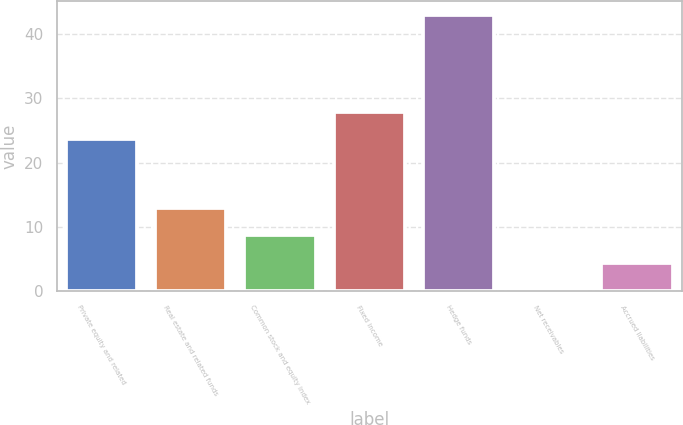Convert chart to OTSL. <chart><loc_0><loc_0><loc_500><loc_500><bar_chart><fcel>Private equity and related<fcel>Real estate and related funds<fcel>Common stock and equity index<fcel>Fixed income<fcel>Hedge funds<fcel>Net receivables<fcel>Accrued liabilities<nl><fcel>23.6<fcel>12.97<fcel>8.68<fcel>27.89<fcel>43<fcel>0.1<fcel>4.39<nl></chart> 